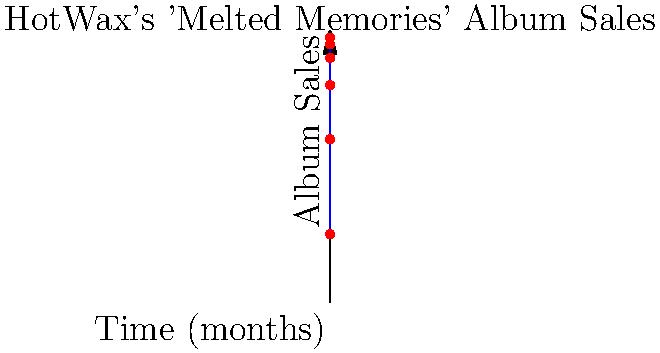HotWax's latest album "Melted Memories" has been a breakthrough success. The graph shows the cumulative album sales over the first 5 months since its release. The sales pattern can be modeled by the function $S(t) = 5000 + 15000(1-e^{-t/2})$, where $S$ is the total sales and $t$ is time in months. Calculate the total number of albums sold during the third month (between $t=2$ and $t=3$) using the area under the curve. To find the number of albums sold during the third month, we need to calculate the area under the curve between $t=2$ and $t=3$. This can be done using a definite integral.

1) The function for album sales is $S(t) = 5000 + 15000(1-e^{-t/2})$

2) We need to integrate this function from $t=2$ to $t=3$:

   $$\int_{2}^{3} [5000 + 15000(1-e^{-t/2})] dt$$

3) Simplify the integral:
   
   $$\int_{2}^{3} [5000 + 15000 - 15000e^{-t/2}] dt$$
   
   $$= \int_{2}^{3} [20000 - 15000e^{-t/2}] dt$$

4) Integrate:
   
   $$= [20000t + 30000e^{-t/2}]_{2}^{3}$$

5) Evaluate the bounds:
   
   $$= (60000 + 30000e^{-3/2}) - (40000 + 30000e^{-1})$$

6) Calculate:
   
   $$\approx 60000 + 5505 - 40000 - 11040 = 14465$$

Therefore, approximately 14,465 albums were sold during the third month.
Answer: 14,465 albums 